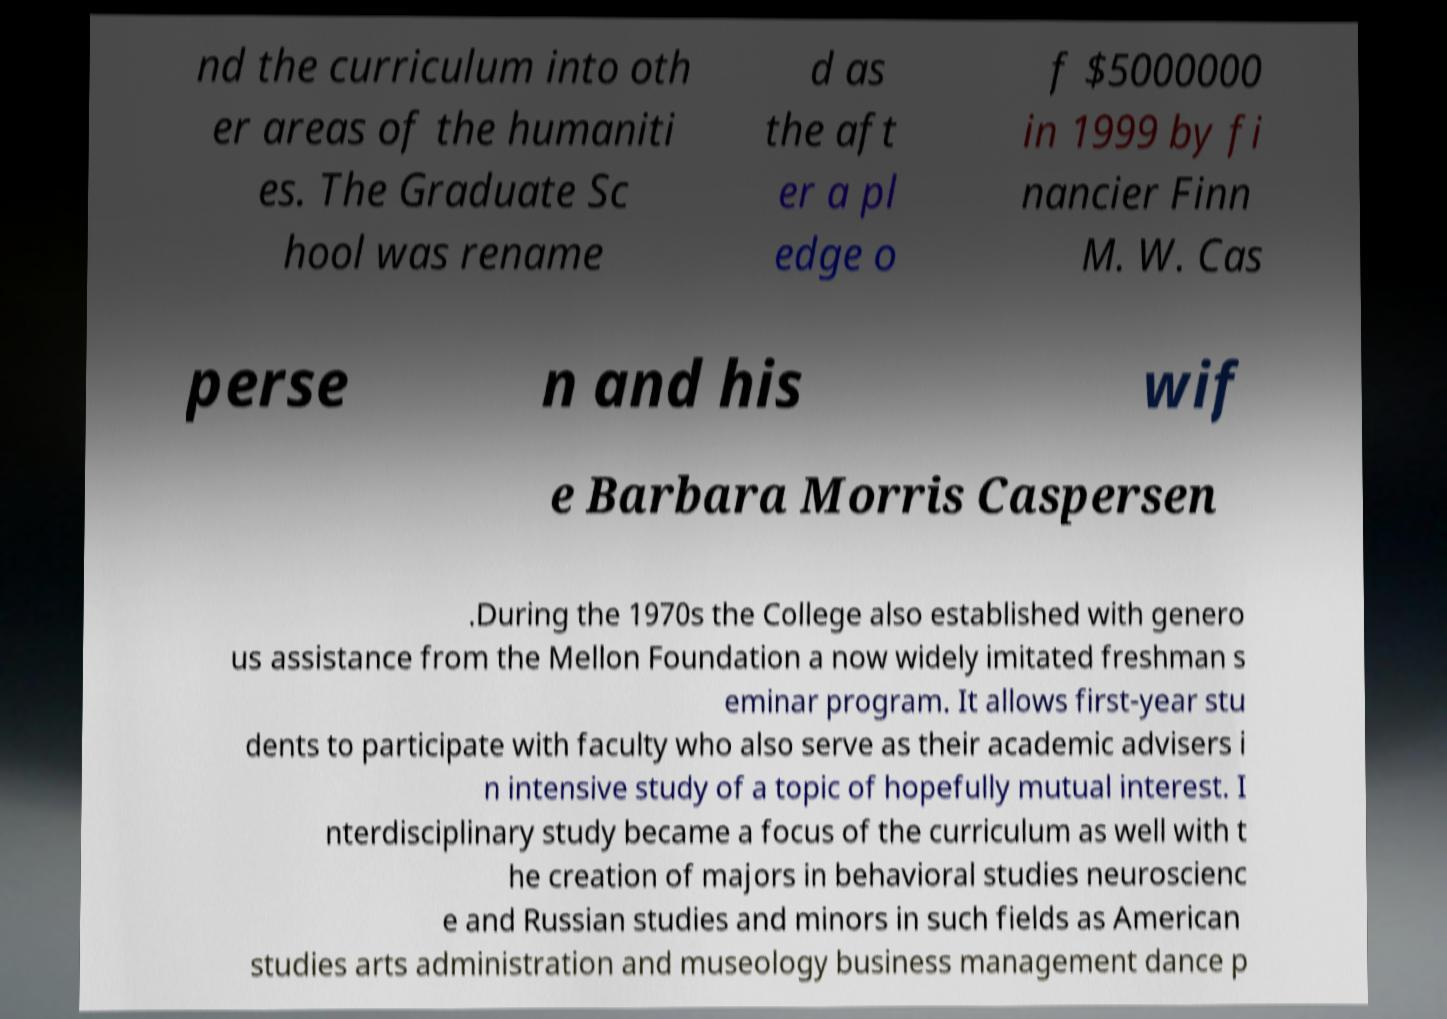Please read and relay the text visible in this image. What does it say? nd the curriculum into oth er areas of the humaniti es. The Graduate Sc hool was rename d as the aft er a pl edge o f $5000000 in 1999 by fi nancier Finn M. W. Cas perse n and his wif e Barbara Morris Caspersen .During the 1970s the College also established with genero us assistance from the Mellon Foundation a now widely imitated freshman s eminar program. It allows first-year stu dents to participate with faculty who also serve as their academic advisers i n intensive study of a topic of hopefully mutual interest. I nterdisciplinary study became a focus of the curriculum as well with t he creation of majors in behavioral studies neuroscienc e and Russian studies and minors in such fields as American studies arts administration and museology business management dance p 